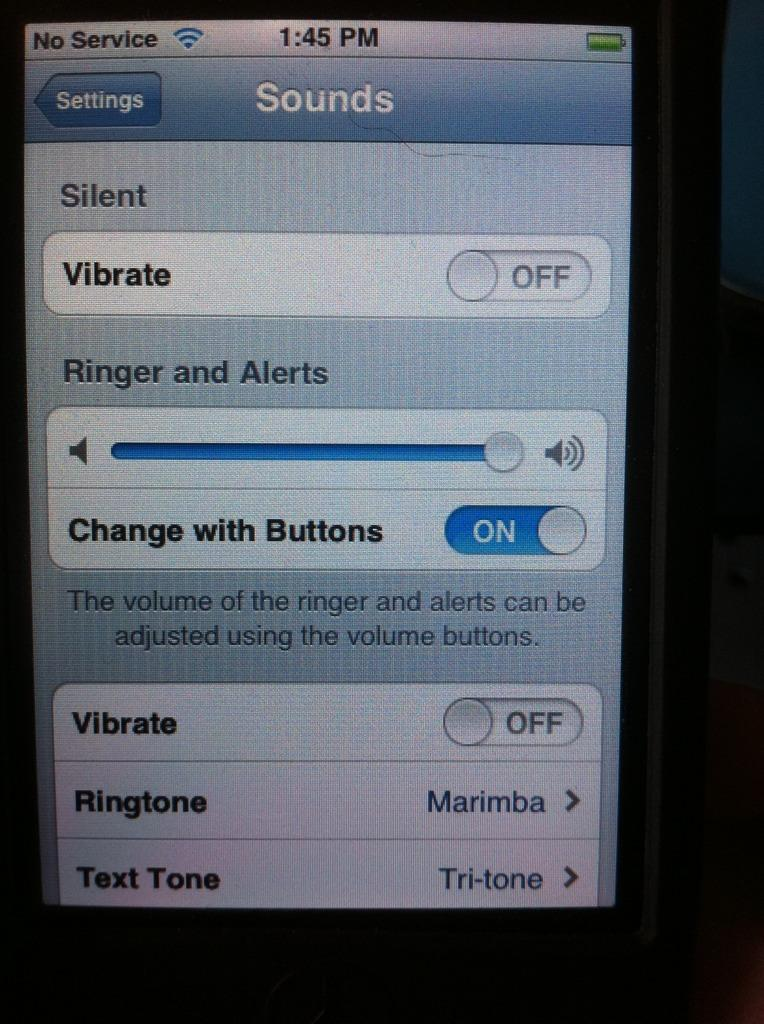Provide a one-sentence caption for the provided image. A phone screen shows that vibrate is set to off. 